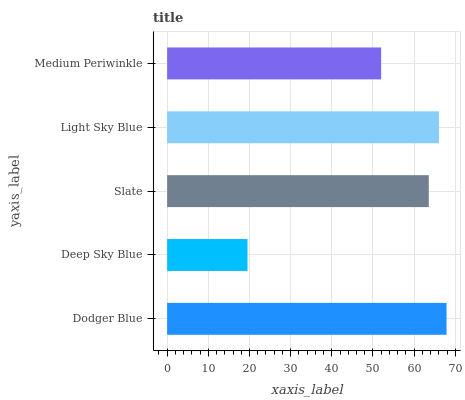Is Deep Sky Blue the minimum?
Answer yes or no. Yes. Is Dodger Blue the maximum?
Answer yes or no. Yes. Is Slate the minimum?
Answer yes or no. No. Is Slate the maximum?
Answer yes or no. No. Is Slate greater than Deep Sky Blue?
Answer yes or no. Yes. Is Deep Sky Blue less than Slate?
Answer yes or no. Yes. Is Deep Sky Blue greater than Slate?
Answer yes or no. No. Is Slate less than Deep Sky Blue?
Answer yes or no. No. Is Slate the high median?
Answer yes or no. Yes. Is Slate the low median?
Answer yes or no. Yes. Is Light Sky Blue the high median?
Answer yes or no. No. Is Medium Periwinkle the low median?
Answer yes or no. No. 